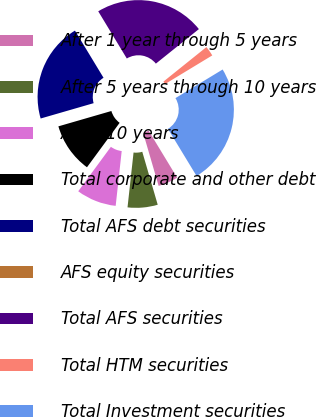Convert chart to OTSL. <chart><loc_0><loc_0><loc_500><loc_500><pie_chart><fcel>After 1 year through 5 years<fcel>After 5 years through 10 years<fcel>After 10 years<fcel>Total corporate and other debt<fcel>Total AFS debt securities<fcel>AFS equity securities<fcel>Total AFS securities<fcel>Total HTM securities<fcel>Total Investment securities<nl><fcel>4.17%<fcel>6.26%<fcel>8.34%<fcel>10.43%<fcel>20.82%<fcel>0.0%<fcel>22.9%<fcel>2.09%<fcel>24.99%<nl></chart> 